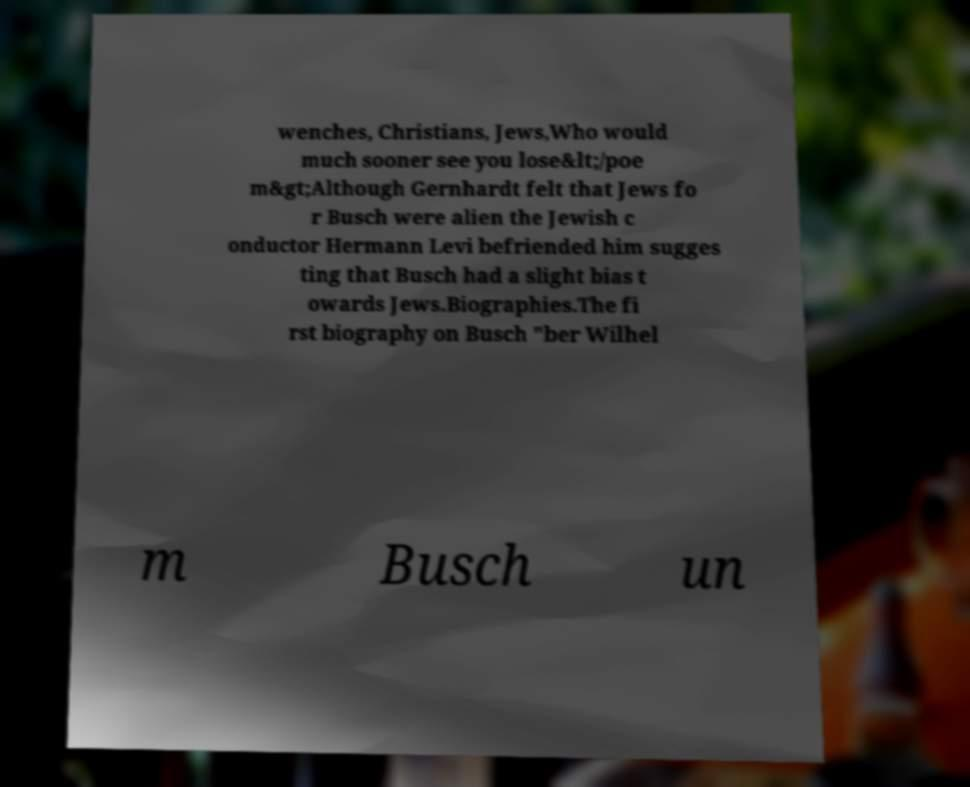There's text embedded in this image that I need extracted. Can you transcribe it verbatim? wenches, Christians, Jews,Who would much sooner see you lose&lt;/poe m&gt;Although Gernhardt felt that Jews fo r Busch were alien the Jewish c onductor Hermann Levi befriended him sugges ting that Busch had a slight bias t owards Jews.Biographies.The fi rst biography on Busch "ber Wilhel m Busch un 